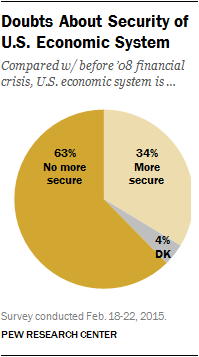Specify some key components in this picture. In this study, 38% of participants chose the secure option and indicated that they don't know. The most popular option is not secure. 